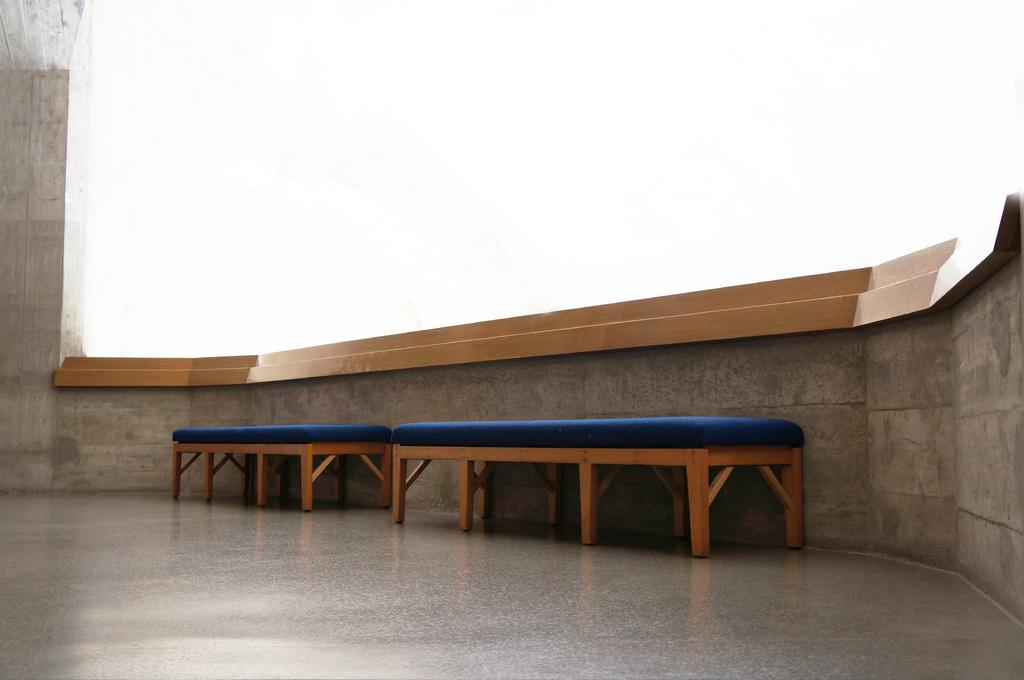What part of a building can be seen in the image? The image shows the inner part of a building. What is one of the main features of the building's interior? There is a wall visible in the image. What type of furniture is present in the image? There are blue-colored stools in the image. What type of engine can be seen in the image? There is no engine present in the image; it shows the inner part of a building with a wall and blue-colored stools. 